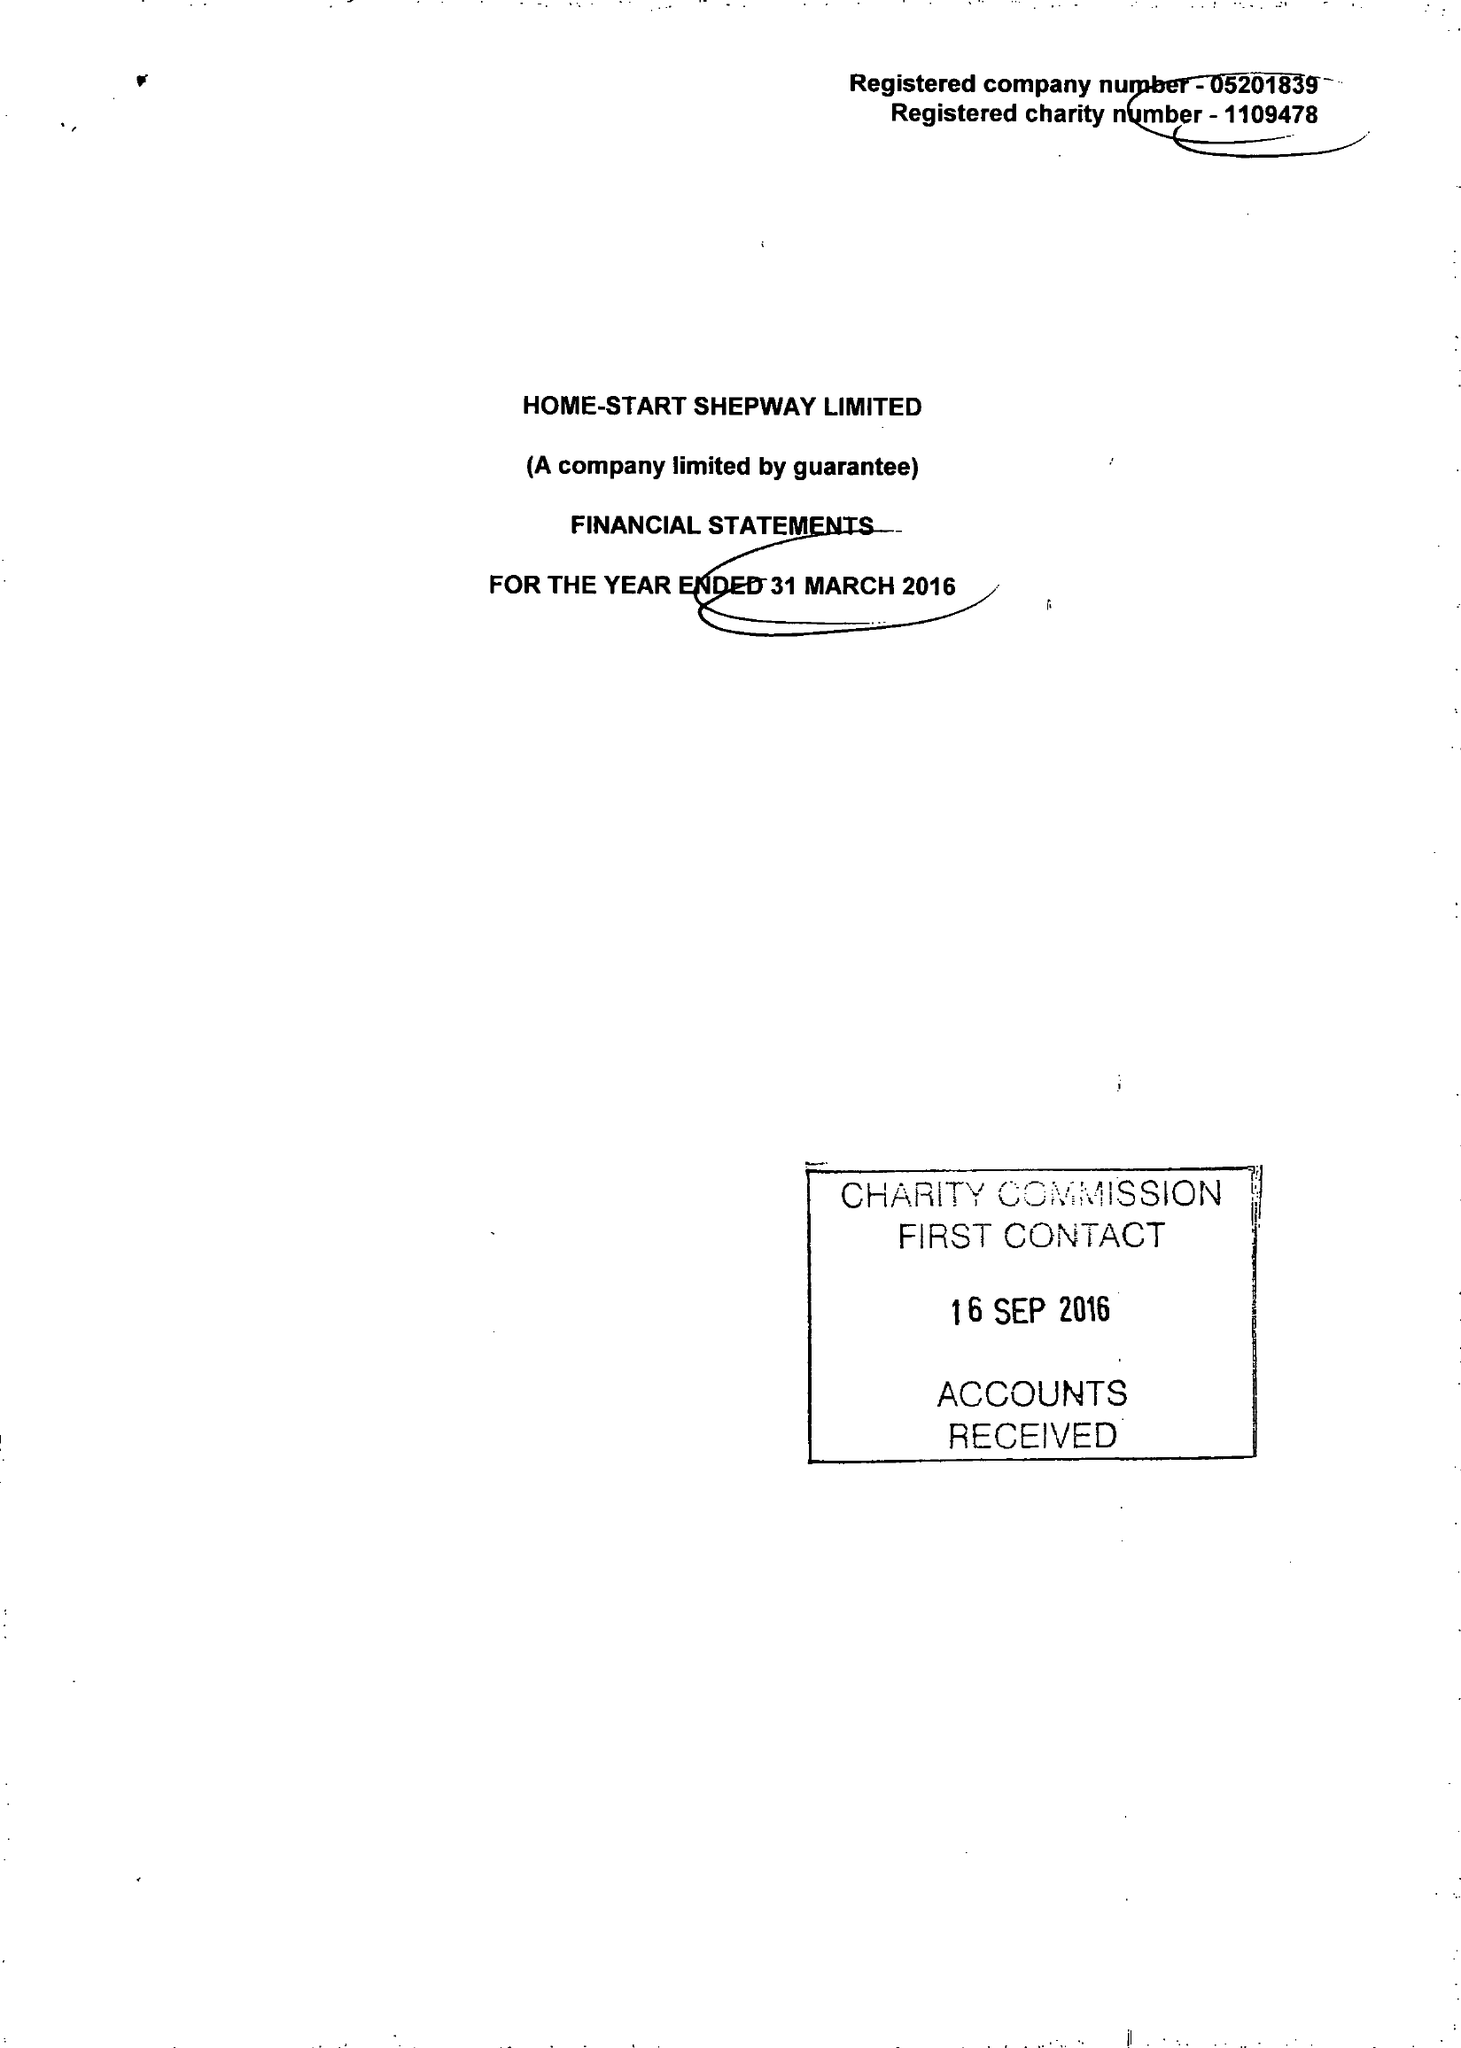What is the value for the address__post_town?
Answer the question using a single word or phrase. FOLKESTONE 